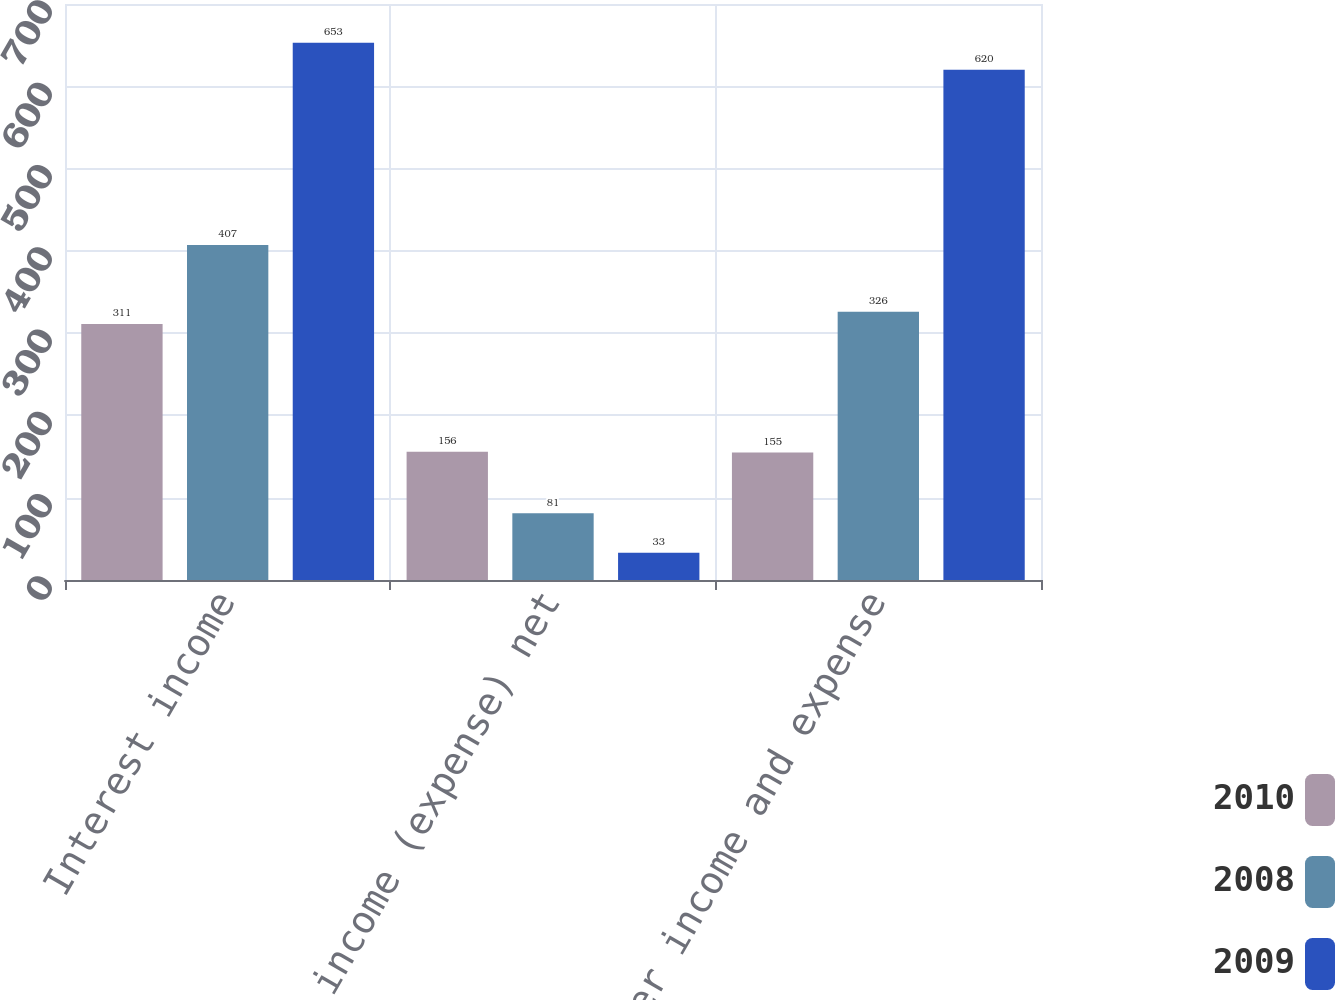Convert chart. <chart><loc_0><loc_0><loc_500><loc_500><stacked_bar_chart><ecel><fcel>Interest income<fcel>Other income (expense) net<fcel>Total other income and expense<nl><fcel>2010<fcel>311<fcel>156<fcel>155<nl><fcel>2008<fcel>407<fcel>81<fcel>326<nl><fcel>2009<fcel>653<fcel>33<fcel>620<nl></chart> 